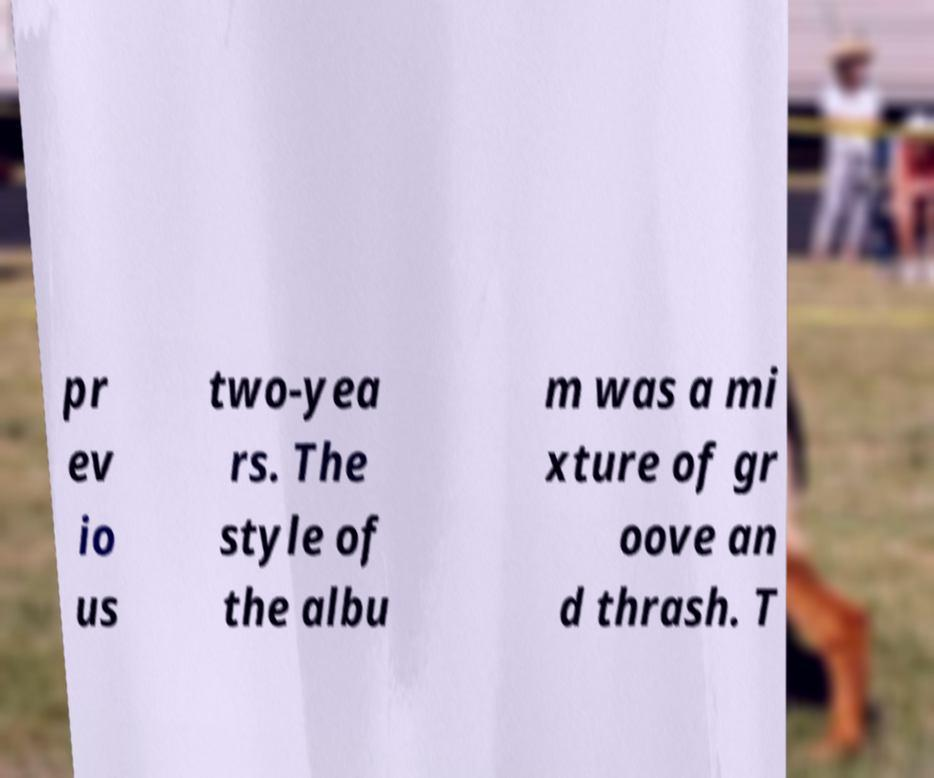For documentation purposes, I need the text within this image transcribed. Could you provide that? pr ev io us two-yea rs. The style of the albu m was a mi xture of gr oove an d thrash. T 